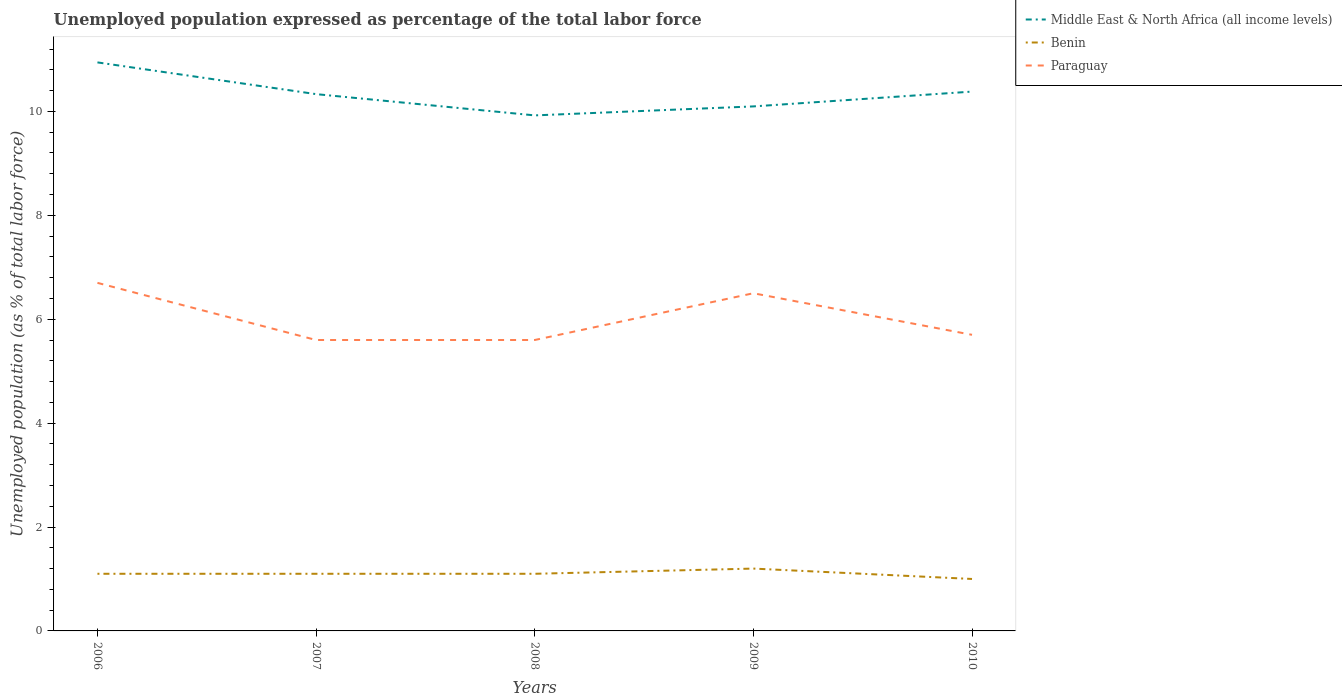In which year was the unemployment in in Benin maximum?
Your answer should be compact. 2010. What is the total unemployment in in Paraguay in the graph?
Give a very brief answer. -0.9. What is the difference between the highest and the second highest unemployment in in Middle East & North Africa (all income levels)?
Make the answer very short. 1.02. Is the unemployment in in Benin strictly greater than the unemployment in in Paraguay over the years?
Offer a terse response. Yes. How many lines are there?
Your answer should be compact. 3. How many years are there in the graph?
Offer a terse response. 5. What is the difference between two consecutive major ticks on the Y-axis?
Your response must be concise. 2. Are the values on the major ticks of Y-axis written in scientific E-notation?
Provide a short and direct response. No. How are the legend labels stacked?
Give a very brief answer. Vertical. What is the title of the graph?
Your answer should be compact. Unemployed population expressed as percentage of the total labor force. What is the label or title of the Y-axis?
Offer a terse response. Unemployed population (as % of total labor force). What is the Unemployed population (as % of total labor force) in Middle East & North Africa (all income levels) in 2006?
Offer a very short reply. 10.94. What is the Unemployed population (as % of total labor force) of Benin in 2006?
Make the answer very short. 1.1. What is the Unemployed population (as % of total labor force) in Paraguay in 2006?
Your response must be concise. 6.7. What is the Unemployed population (as % of total labor force) of Middle East & North Africa (all income levels) in 2007?
Your answer should be very brief. 10.33. What is the Unemployed population (as % of total labor force) in Benin in 2007?
Give a very brief answer. 1.1. What is the Unemployed population (as % of total labor force) in Paraguay in 2007?
Provide a short and direct response. 5.6. What is the Unemployed population (as % of total labor force) of Middle East & North Africa (all income levels) in 2008?
Your response must be concise. 9.92. What is the Unemployed population (as % of total labor force) of Benin in 2008?
Keep it short and to the point. 1.1. What is the Unemployed population (as % of total labor force) in Paraguay in 2008?
Ensure brevity in your answer.  5.6. What is the Unemployed population (as % of total labor force) in Middle East & North Africa (all income levels) in 2009?
Make the answer very short. 10.1. What is the Unemployed population (as % of total labor force) of Benin in 2009?
Your response must be concise. 1.2. What is the Unemployed population (as % of total labor force) of Middle East & North Africa (all income levels) in 2010?
Give a very brief answer. 10.38. What is the Unemployed population (as % of total labor force) in Paraguay in 2010?
Provide a succinct answer. 5.7. Across all years, what is the maximum Unemployed population (as % of total labor force) in Middle East & North Africa (all income levels)?
Provide a succinct answer. 10.94. Across all years, what is the maximum Unemployed population (as % of total labor force) of Benin?
Give a very brief answer. 1.2. Across all years, what is the maximum Unemployed population (as % of total labor force) in Paraguay?
Offer a terse response. 6.7. Across all years, what is the minimum Unemployed population (as % of total labor force) of Middle East & North Africa (all income levels)?
Your response must be concise. 9.92. Across all years, what is the minimum Unemployed population (as % of total labor force) in Benin?
Keep it short and to the point. 1. Across all years, what is the minimum Unemployed population (as % of total labor force) of Paraguay?
Your answer should be compact. 5.6. What is the total Unemployed population (as % of total labor force) in Middle East & North Africa (all income levels) in the graph?
Provide a short and direct response. 51.68. What is the total Unemployed population (as % of total labor force) of Paraguay in the graph?
Provide a short and direct response. 30.1. What is the difference between the Unemployed population (as % of total labor force) of Middle East & North Africa (all income levels) in 2006 and that in 2007?
Offer a very short reply. 0.61. What is the difference between the Unemployed population (as % of total labor force) in Paraguay in 2006 and that in 2007?
Your answer should be compact. 1.1. What is the difference between the Unemployed population (as % of total labor force) of Middle East & North Africa (all income levels) in 2006 and that in 2008?
Offer a terse response. 1.02. What is the difference between the Unemployed population (as % of total labor force) in Benin in 2006 and that in 2008?
Provide a succinct answer. 0. What is the difference between the Unemployed population (as % of total labor force) of Paraguay in 2006 and that in 2008?
Offer a very short reply. 1.1. What is the difference between the Unemployed population (as % of total labor force) of Middle East & North Africa (all income levels) in 2006 and that in 2009?
Your answer should be very brief. 0.85. What is the difference between the Unemployed population (as % of total labor force) of Middle East & North Africa (all income levels) in 2006 and that in 2010?
Keep it short and to the point. 0.56. What is the difference between the Unemployed population (as % of total labor force) of Paraguay in 2006 and that in 2010?
Provide a succinct answer. 1. What is the difference between the Unemployed population (as % of total labor force) in Middle East & North Africa (all income levels) in 2007 and that in 2008?
Make the answer very short. 0.41. What is the difference between the Unemployed population (as % of total labor force) in Benin in 2007 and that in 2008?
Provide a short and direct response. 0. What is the difference between the Unemployed population (as % of total labor force) in Middle East & North Africa (all income levels) in 2007 and that in 2009?
Provide a succinct answer. 0.24. What is the difference between the Unemployed population (as % of total labor force) in Benin in 2007 and that in 2009?
Provide a succinct answer. -0.1. What is the difference between the Unemployed population (as % of total labor force) in Paraguay in 2007 and that in 2009?
Make the answer very short. -0.9. What is the difference between the Unemployed population (as % of total labor force) of Middle East & North Africa (all income levels) in 2007 and that in 2010?
Keep it short and to the point. -0.05. What is the difference between the Unemployed population (as % of total labor force) of Middle East & North Africa (all income levels) in 2008 and that in 2009?
Offer a very short reply. -0.17. What is the difference between the Unemployed population (as % of total labor force) in Benin in 2008 and that in 2009?
Your response must be concise. -0.1. What is the difference between the Unemployed population (as % of total labor force) of Paraguay in 2008 and that in 2009?
Keep it short and to the point. -0.9. What is the difference between the Unemployed population (as % of total labor force) in Middle East & North Africa (all income levels) in 2008 and that in 2010?
Provide a short and direct response. -0.46. What is the difference between the Unemployed population (as % of total labor force) of Benin in 2008 and that in 2010?
Provide a succinct answer. 0.1. What is the difference between the Unemployed population (as % of total labor force) in Middle East & North Africa (all income levels) in 2009 and that in 2010?
Offer a terse response. -0.29. What is the difference between the Unemployed population (as % of total labor force) in Paraguay in 2009 and that in 2010?
Ensure brevity in your answer.  0.8. What is the difference between the Unemployed population (as % of total labor force) of Middle East & North Africa (all income levels) in 2006 and the Unemployed population (as % of total labor force) of Benin in 2007?
Provide a short and direct response. 9.84. What is the difference between the Unemployed population (as % of total labor force) in Middle East & North Africa (all income levels) in 2006 and the Unemployed population (as % of total labor force) in Paraguay in 2007?
Your response must be concise. 5.34. What is the difference between the Unemployed population (as % of total labor force) in Middle East & North Africa (all income levels) in 2006 and the Unemployed population (as % of total labor force) in Benin in 2008?
Keep it short and to the point. 9.84. What is the difference between the Unemployed population (as % of total labor force) of Middle East & North Africa (all income levels) in 2006 and the Unemployed population (as % of total labor force) of Paraguay in 2008?
Keep it short and to the point. 5.34. What is the difference between the Unemployed population (as % of total labor force) in Middle East & North Africa (all income levels) in 2006 and the Unemployed population (as % of total labor force) in Benin in 2009?
Your response must be concise. 9.74. What is the difference between the Unemployed population (as % of total labor force) in Middle East & North Africa (all income levels) in 2006 and the Unemployed population (as % of total labor force) in Paraguay in 2009?
Your answer should be very brief. 4.44. What is the difference between the Unemployed population (as % of total labor force) of Benin in 2006 and the Unemployed population (as % of total labor force) of Paraguay in 2009?
Provide a short and direct response. -5.4. What is the difference between the Unemployed population (as % of total labor force) in Middle East & North Africa (all income levels) in 2006 and the Unemployed population (as % of total labor force) in Benin in 2010?
Keep it short and to the point. 9.94. What is the difference between the Unemployed population (as % of total labor force) in Middle East & North Africa (all income levels) in 2006 and the Unemployed population (as % of total labor force) in Paraguay in 2010?
Keep it short and to the point. 5.24. What is the difference between the Unemployed population (as % of total labor force) in Middle East & North Africa (all income levels) in 2007 and the Unemployed population (as % of total labor force) in Benin in 2008?
Keep it short and to the point. 9.23. What is the difference between the Unemployed population (as % of total labor force) in Middle East & North Africa (all income levels) in 2007 and the Unemployed population (as % of total labor force) in Paraguay in 2008?
Keep it short and to the point. 4.73. What is the difference between the Unemployed population (as % of total labor force) in Benin in 2007 and the Unemployed population (as % of total labor force) in Paraguay in 2008?
Offer a terse response. -4.5. What is the difference between the Unemployed population (as % of total labor force) in Middle East & North Africa (all income levels) in 2007 and the Unemployed population (as % of total labor force) in Benin in 2009?
Keep it short and to the point. 9.13. What is the difference between the Unemployed population (as % of total labor force) of Middle East & North Africa (all income levels) in 2007 and the Unemployed population (as % of total labor force) of Paraguay in 2009?
Provide a short and direct response. 3.83. What is the difference between the Unemployed population (as % of total labor force) in Middle East & North Africa (all income levels) in 2007 and the Unemployed population (as % of total labor force) in Benin in 2010?
Offer a terse response. 9.33. What is the difference between the Unemployed population (as % of total labor force) of Middle East & North Africa (all income levels) in 2007 and the Unemployed population (as % of total labor force) of Paraguay in 2010?
Your response must be concise. 4.63. What is the difference between the Unemployed population (as % of total labor force) in Benin in 2007 and the Unemployed population (as % of total labor force) in Paraguay in 2010?
Ensure brevity in your answer.  -4.6. What is the difference between the Unemployed population (as % of total labor force) in Middle East & North Africa (all income levels) in 2008 and the Unemployed population (as % of total labor force) in Benin in 2009?
Provide a short and direct response. 8.72. What is the difference between the Unemployed population (as % of total labor force) of Middle East & North Africa (all income levels) in 2008 and the Unemployed population (as % of total labor force) of Paraguay in 2009?
Provide a succinct answer. 3.42. What is the difference between the Unemployed population (as % of total labor force) in Benin in 2008 and the Unemployed population (as % of total labor force) in Paraguay in 2009?
Your answer should be very brief. -5.4. What is the difference between the Unemployed population (as % of total labor force) in Middle East & North Africa (all income levels) in 2008 and the Unemployed population (as % of total labor force) in Benin in 2010?
Provide a succinct answer. 8.92. What is the difference between the Unemployed population (as % of total labor force) of Middle East & North Africa (all income levels) in 2008 and the Unemployed population (as % of total labor force) of Paraguay in 2010?
Offer a very short reply. 4.22. What is the difference between the Unemployed population (as % of total labor force) in Benin in 2008 and the Unemployed population (as % of total labor force) in Paraguay in 2010?
Your answer should be compact. -4.6. What is the difference between the Unemployed population (as % of total labor force) in Middle East & North Africa (all income levels) in 2009 and the Unemployed population (as % of total labor force) in Benin in 2010?
Offer a terse response. 9.1. What is the difference between the Unemployed population (as % of total labor force) in Middle East & North Africa (all income levels) in 2009 and the Unemployed population (as % of total labor force) in Paraguay in 2010?
Offer a terse response. 4.4. What is the average Unemployed population (as % of total labor force) of Middle East & North Africa (all income levels) per year?
Your answer should be compact. 10.34. What is the average Unemployed population (as % of total labor force) of Paraguay per year?
Your response must be concise. 6.02. In the year 2006, what is the difference between the Unemployed population (as % of total labor force) of Middle East & North Africa (all income levels) and Unemployed population (as % of total labor force) of Benin?
Make the answer very short. 9.84. In the year 2006, what is the difference between the Unemployed population (as % of total labor force) in Middle East & North Africa (all income levels) and Unemployed population (as % of total labor force) in Paraguay?
Give a very brief answer. 4.24. In the year 2006, what is the difference between the Unemployed population (as % of total labor force) in Benin and Unemployed population (as % of total labor force) in Paraguay?
Offer a terse response. -5.6. In the year 2007, what is the difference between the Unemployed population (as % of total labor force) of Middle East & North Africa (all income levels) and Unemployed population (as % of total labor force) of Benin?
Keep it short and to the point. 9.23. In the year 2007, what is the difference between the Unemployed population (as % of total labor force) of Middle East & North Africa (all income levels) and Unemployed population (as % of total labor force) of Paraguay?
Provide a succinct answer. 4.73. In the year 2008, what is the difference between the Unemployed population (as % of total labor force) of Middle East & North Africa (all income levels) and Unemployed population (as % of total labor force) of Benin?
Your answer should be compact. 8.82. In the year 2008, what is the difference between the Unemployed population (as % of total labor force) in Middle East & North Africa (all income levels) and Unemployed population (as % of total labor force) in Paraguay?
Make the answer very short. 4.32. In the year 2008, what is the difference between the Unemployed population (as % of total labor force) of Benin and Unemployed population (as % of total labor force) of Paraguay?
Give a very brief answer. -4.5. In the year 2009, what is the difference between the Unemployed population (as % of total labor force) of Middle East & North Africa (all income levels) and Unemployed population (as % of total labor force) of Benin?
Keep it short and to the point. 8.9. In the year 2009, what is the difference between the Unemployed population (as % of total labor force) in Middle East & North Africa (all income levels) and Unemployed population (as % of total labor force) in Paraguay?
Keep it short and to the point. 3.6. In the year 2010, what is the difference between the Unemployed population (as % of total labor force) of Middle East & North Africa (all income levels) and Unemployed population (as % of total labor force) of Benin?
Ensure brevity in your answer.  9.38. In the year 2010, what is the difference between the Unemployed population (as % of total labor force) of Middle East & North Africa (all income levels) and Unemployed population (as % of total labor force) of Paraguay?
Offer a terse response. 4.68. What is the ratio of the Unemployed population (as % of total labor force) in Middle East & North Africa (all income levels) in 2006 to that in 2007?
Ensure brevity in your answer.  1.06. What is the ratio of the Unemployed population (as % of total labor force) of Paraguay in 2006 to that in 2007?
Keep it short and to the point. 1.2. What is the ratio of the Unemployed population (as % of total labor force) in Middle East & North Africa (all income levels) in 2006 to that in 2008?
Provide a succinct answer. 1.1. What is the ratio of the Unemployed population (as % of total labor force) in Benin in 2006 to that in 2008?
Provide a short and direct response. 1. What is the ratio of the Unemployed population (as % of total labor force) in Paraguay in 2006 to that in 2008?
Offer a very short reply. 1.2. What is the ratio of the Unemployed population (as % of total labor force) in Middle East & North Africa (all income levels) in 2006 to that in 2009?
Your answer should be very brief. 1.08. What is the ratio of the Unemployed population (as % of total labor force) in Paraguay in 2006 to that in 2009?
Make the answer very short. 1.03. What is the ratio of the Unemployed population (as % of total labor force) in Middle East & North Africa (all income levels) in 2006 to that in 2010?
Your answer should be very brief. 1.05. What is the ratio of the Unemployed population (as % of total labor force) of Paraguay in 2006 to that in 2010?
Ensure brevity in your answer.  1.18. What is the ratio of the Unemployed population (as % of total labor force) of Middle East & North Africa (all income levels) in 2007 to that in 2008?
Provide a succinct answer. 1.04. What is the ratio of the Unemployed population (as % of total labor force) in Paraguay in 2007 to that in 2008?
Offer a very short reply. 1. What is the ratio of the Unemployed population (as % of total labor force) of Middle East & North Africa (all income levels) in 2007 to that in 2009?
Provide a short and direct response. 1.02. What is the ratio of the Unemployed population (as % of total labor force) in Benin in 2007 to that in 2009?
Offer a terse response. 0.92. What is the ratio of the Unemployed population (as % of total labor force) of Paraguay in 2007 to that in 2009?
Provide a short and direct response. 0.86. What is the ratio of the Unemployed population (as % of total labor force) in Paraguay in 2007 to that in 2010?
Ensure brevity in your answer.  0.98. What is the ratio of the Unemployed population (as % of total labor force) in Middle East & North Africa (all income levels) in 2008 to that in 2009?
Give a very brief answer. 0.98. What is the ratio of the Unemployed population (as % of total labor force) in Benin in 2008 to that in 2009?
Offer a very short reply. 0.92. What is the ratio of the Unemployed population (as % of total labor force) in Paraguay in 2008 to that in 2009?
Keep it short and to the point. 0.86. What is the ratio of the Unemployed population (as % of total labor force) in Middle East & North Africa (all income levels) in 2008 to that in 2010?
Offer a terse response. 0.96. What is the ratio of the Unemployed population (as % of total labor force) of Benin in 2008 to that in 2010?
Give a very brief answer. 1.1. What is the ratio of the Unemployed population (as % of total labor force) of Paraguay in 2008 to that in 2010?
Give a very brief answer. 0.98. What is the ratio of the Unemployed population (as % of total labor force) of Middle East & North Africa (all income levels) in 2009 to that in 2010?
Your answer should be very brief. 0.97. What is the ratio of the Unemployed population (as % of total labor force) in Benin in 2009 to that in 2010?
Your answer should be compact. 1.2. What is the ratio of the Unemployed population (as % of total labor force) of Paraguay in 2009 to that in 2010?
Your answer should be compact. 1.14. What is the difference between the highest and the second highest Unemployed population (as % of total labor force) of Middle East & North Africa (all income levels)?
Make the answer very short. 0.56. What is the difference between the highest and the second highest Unemployed population (as % of total labor force) of Paraguay?
Provide a short and direct response. 0.2. What is the difference between the highest and the lowest Unemployed population (as % of total labor force) in Benin?
Provide a short and direct response. 0.2. 